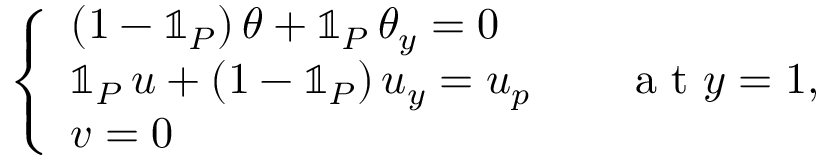<formula> <loc_0><loc_0><loc_500><loc_500>\left \{ \begin{array} { l l } { ( 1 - \mathbb { 1 } _ { P } ) \, \theta + \mathbb { 1 } _ { P } \, \theta _ { y } = 0 } \\ { \mathbb { 1 } _ { P } \, u + ( 1 - \mathbb { 1 } _ { P } ) \, u _ { y } = u _ { p } \quad a t y = 1 , } \\ { v = 0 } \end{array}</formula> 